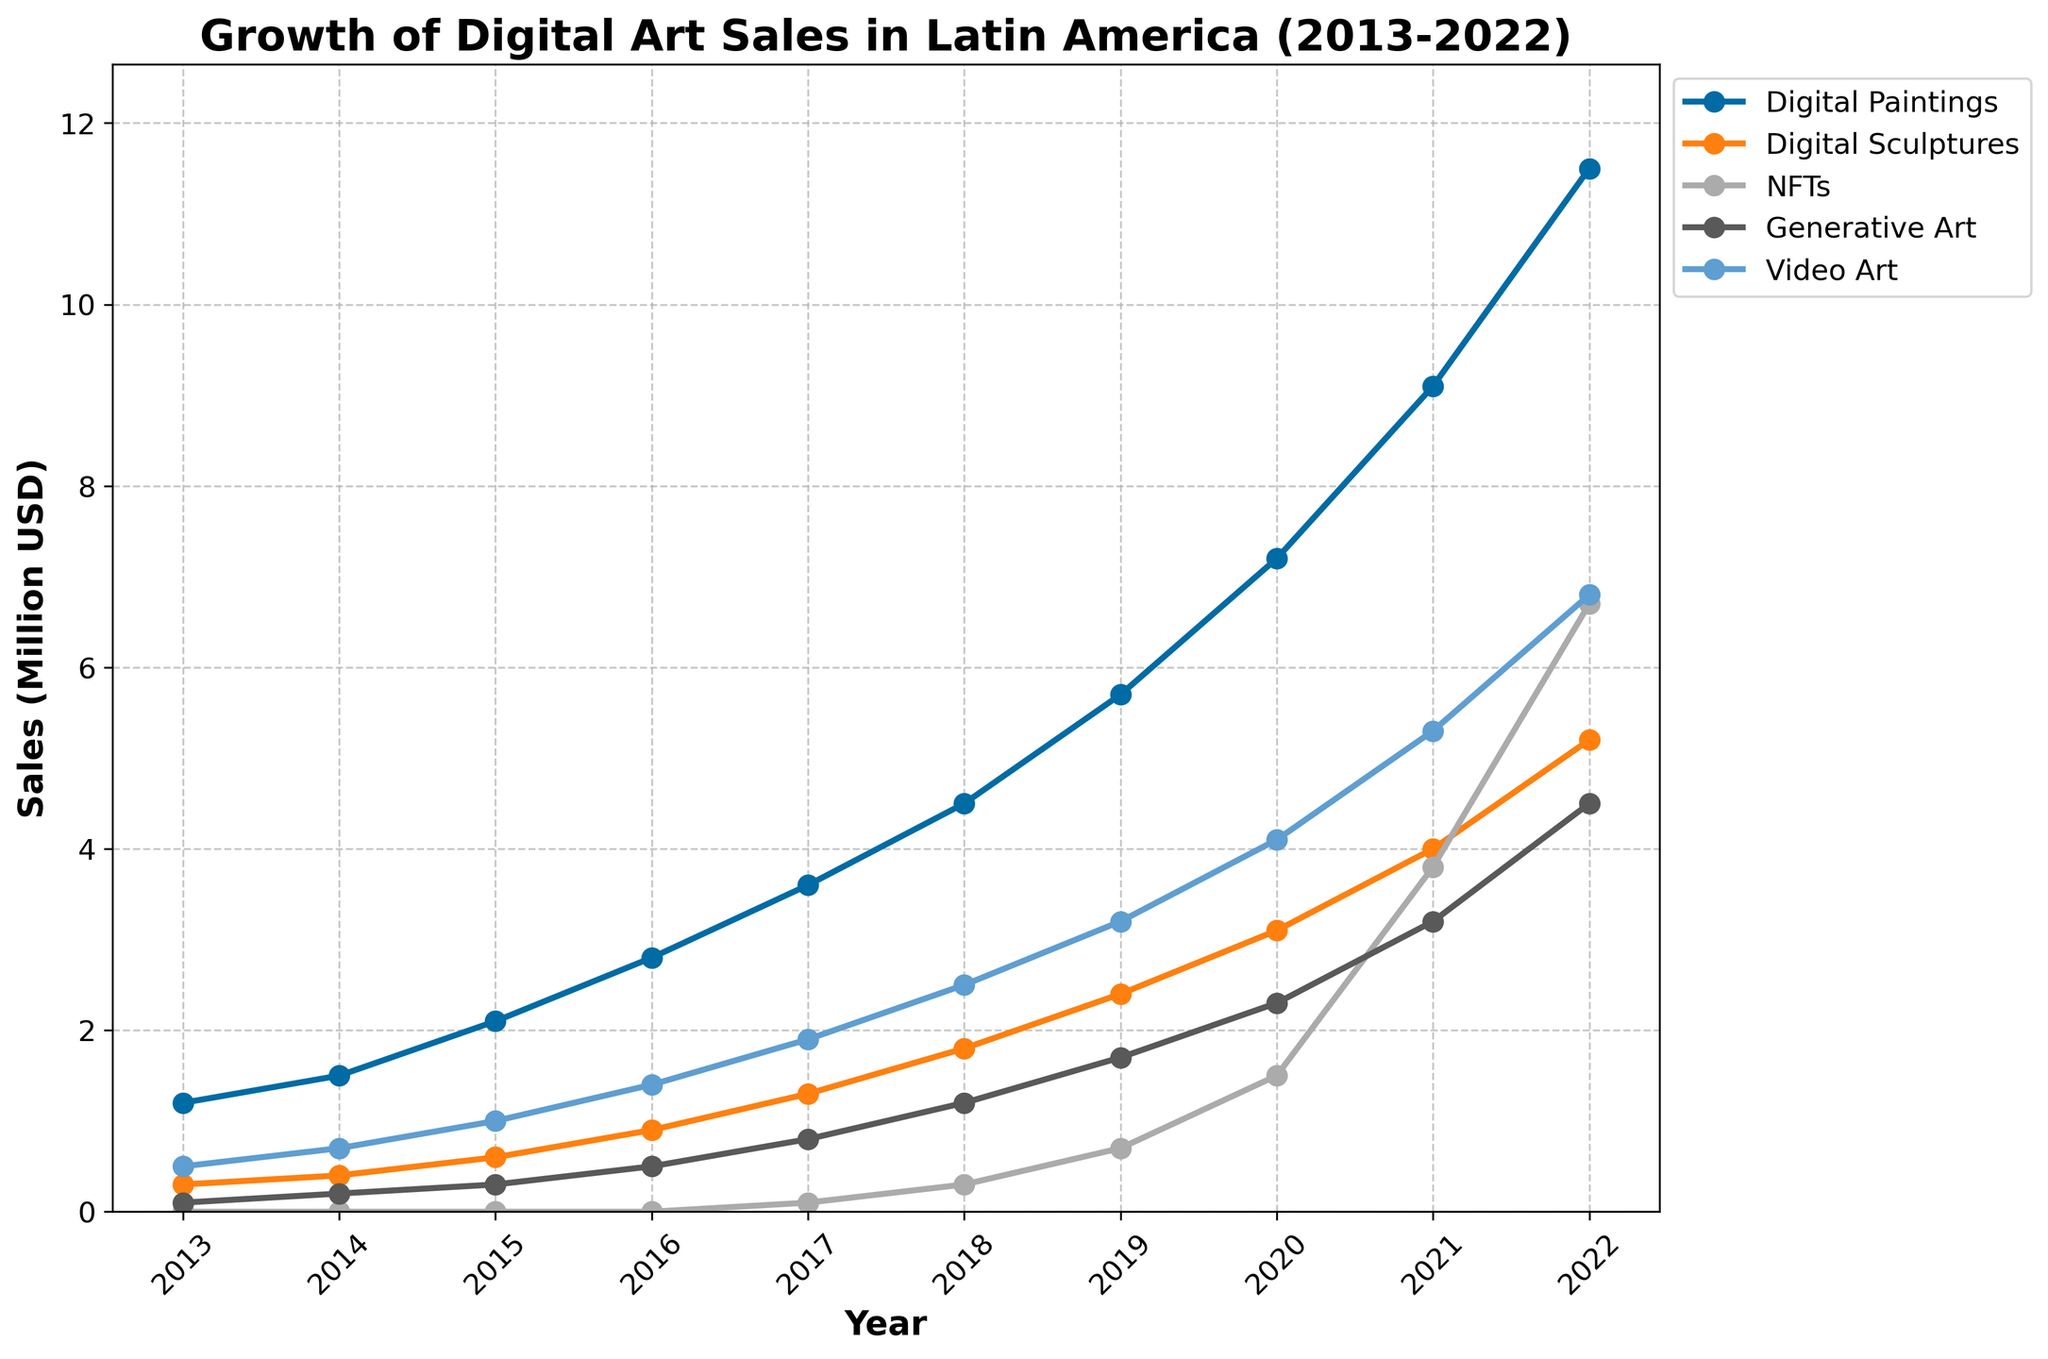What is the overall trend in sales of Digital Paintings from 2013 to 2022? The sales of Digital Paintings show a consistent upward trend, increasing from 1.2 million USD in 2013 to 11.5 million USD in 2022.
Answer: Increasing Which year did NFTs first appear in the data, and what was their sales volume? NFTs first appeared in the data in 2017 with a sales volume of 0.1 million USD.
Answer: 2017, 0.1 million USD How much did the sales of Digital Sculptures increase from 2013 to 2022? The sales of Digital Sculptures increased from 0.3 million USD in 2013 to 5.2 million USD in 2022. The increase is 5.2 - 0.3 = 4.9 million USD.
Answer: 4.9 million USD Which medium saw the highest sales growth in 2022, and what was the sales figure? In 2022, Digital Paintings saw the highest sales growth with a sales figure of 11.5 million USD.
Answer: Digital Paintings, 11.5 million USD Compare the sales of Generative Art and Video Art in 2020. Which one was higher and by how much? In 2020, the sales of Generative Art were 2.3 million USD, and the sales of Video Art were 4.1 million USD. The sales of Video Art were higher by 4.1 - 2.3 = 1.8 million USD.
Answer: Video Art, 1.8 million USD What is the combined sales volume of all media in 2019? The combined sales in 2019 can be found by summing the sales of each medium: 5.7 (Digital Paintings) + 2.4 (Digital Sculptures) + 0.7 (NFTs) + 1.7 (Generative Art) + 3.2 (Video Art) = 13.7 million USD.
Answer: 13.7 million USD Which medium saw the most significant change in sales between 2021 and 2022? NFTs saw the most significant change in sales between 2021 and 2022, increasing from 3.8 million USD to 6.7 million USD, a change of 2.9 million USD.
Answer: NFTs Identify the year when Generative Art's sales first surpassed 2 million USD. Generative Art's sales first surpassed 2 million USD in 2020 with sales of 2.3 million USD.
Answer: 2020 